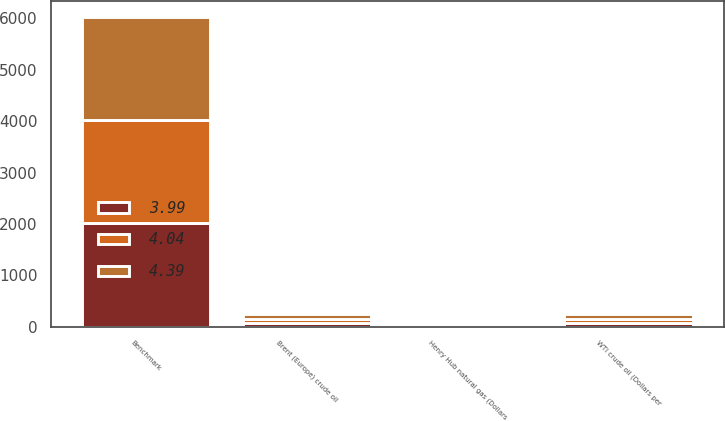Convert chart. <chart><loc_0><loc_0><loc_500><loc_500><stacked_bar_chart><ecel><fcel>Benchmark<fcel>WTI crude oil (Dollars per<fcel>Brent (Europe) crude oil<fcel>Henry Hub natural gas (Dollars<nl><fcel>4.39<fcel>2011<fcel>95.11<fcel>111.26<fcel>4.04<nl><fcel>3.99<fcel>2010<fcel>79.61<fcel>79.51<fcel>4.39<nl><fcel>4.04<fcel>2009<fcel>62.09<fcel>61.49<fcel>3.99<nl></chart> 